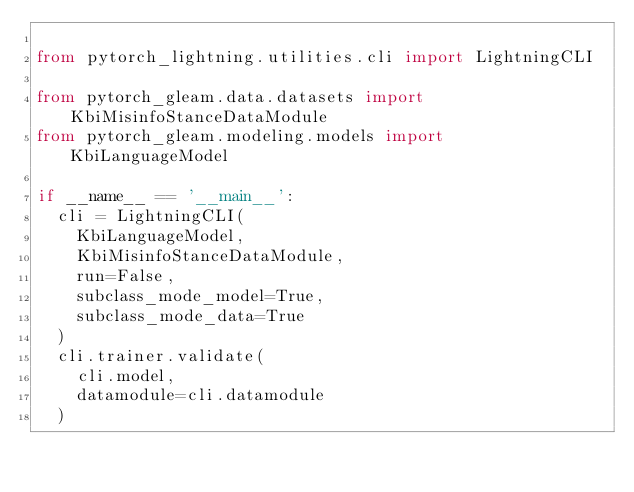<code> <loc_0><loc_0><loc_500><loc_500><_Python_>
from pytorch_lightning.utilities.cli import LightningCLI

from pytorch_gleam.data.datasets import KbiMisinfoStanceDataModule
from pytorch_gleam.modeling.models import KbiLanguageModel

if __name__ == '__main__':
	cli = LightningCLI(
		KbiLanguageModel,
		KbiMisinfoStanceDataModule,
		run=False,
		subclass_mode_model=True,
		subclass_mode_data=True
	)
	cli.trainer.validate(
		cli.model,
		datamodule=cli.datamodule
	)

</code> 